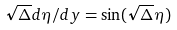<formula> <loc_0><loc_0><loc_500><loc_500>\sqrt { \Delta } d \eta / d y = \sin ( \sqrt { \Delta } \eta )</formula> 